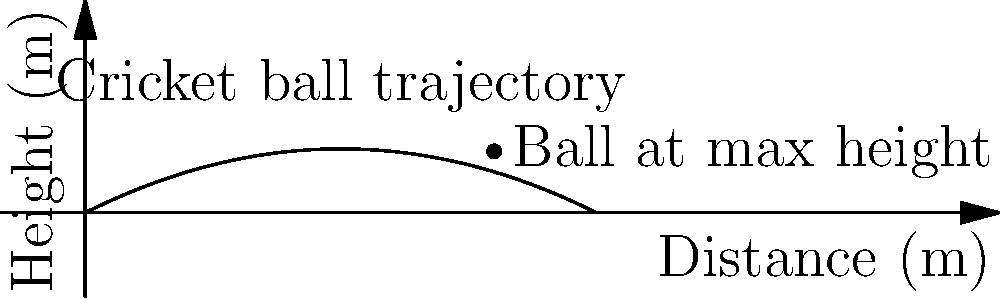During a WBBL match at Adelaide Oval, an Adelaide Strikers bowler delivers a ball that follows a parabolic trajectory. The ball's path can be described by the equation $h = -0.05d^2 + 0.5d$, where $h$ is the height in meters and $d$ is the distance from the bowler in meters. If the ball reaches its maximum height at a distance of 8 meters from the bowler, what is the ball's initial velocity in m/s? To solve this problem, we'll follow these steps:

1) The trajectory equation is $h = -0.05d^2 + 0.5d$

2) For a projectile motion, the general equation is:
   $h = -\frac{1}{2}g(\frac{d}{v_x})^2 + (v_y)(\frac{d}{v_x})$

3) Comparing our equation with the general form:
   $-0.05 = -\frac{1}{2}g(\frac{1}{v_x})^2$
   $0.5 = \frac{v_y}{v_x}$

4) From the first equation:
   $0.05 = \frac{1}{2}g(\frac{1}{v_x})^2$
   $0.1 = g(\frac{1}{v_x})^2$
   $v_x = \sqrt{\frac{g}{0.1}} = \sqrt{\frac{9.8}{0.1}} \approx 9.9$ m/s

5) From the second equation:
   $v_y = 0.5v_x = 0.5 * 9.9 = 4.95$ m/s

6) The initial velocity $v_0$ is:
   $v_0 = \sqrt{v_x^2 + v_y^2} = \sqrt{9.9^2 + 4.95^2} \approx 11.05$ m/s

Therefore, the ball's initial velocity is approximately 11.05 m/s.
Answer: 11.05 m/s 